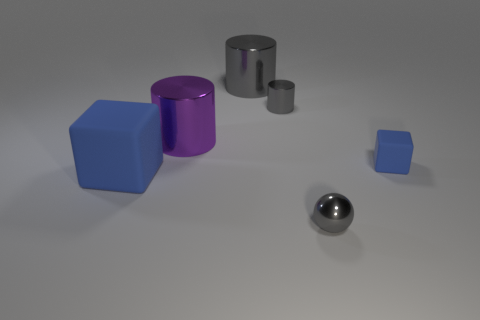Do the matte object that is in front of the small blue thing and the tiny matte object have the same color?
Provide a succinct answer. Yes. How many other objects are there of the same shape as the big rubber object?
Offer a very short reply. 1. How many other things are made of the same material as the big block?
Provide a succinct answer. 1. The blue cube on the left side of the cube to the right of the rubber cube to the left of the large gray metal cylinder is made of what material?
Give a very brief answer. Rubber. Is the tiny blue block made of the same material as the big blue cube?
Give a very brief answer. Yes. What number of spheres are big purple shiny objects or small blue things?
Offer a very short reply. 0. There is a sphere in front of the large blue cube; what color is it?
Provide a succinct answer. Gray. How many matte things are blue cylinders or gray balls?
Provide a short and direct response. 0. What is the tiny object that is in front of the block behind the large blue matte object made of?
Provide a succinct answer. Metal. What is the material of the other block that is the same color as the tiny cube?
Your response must be concise. Rubber. 